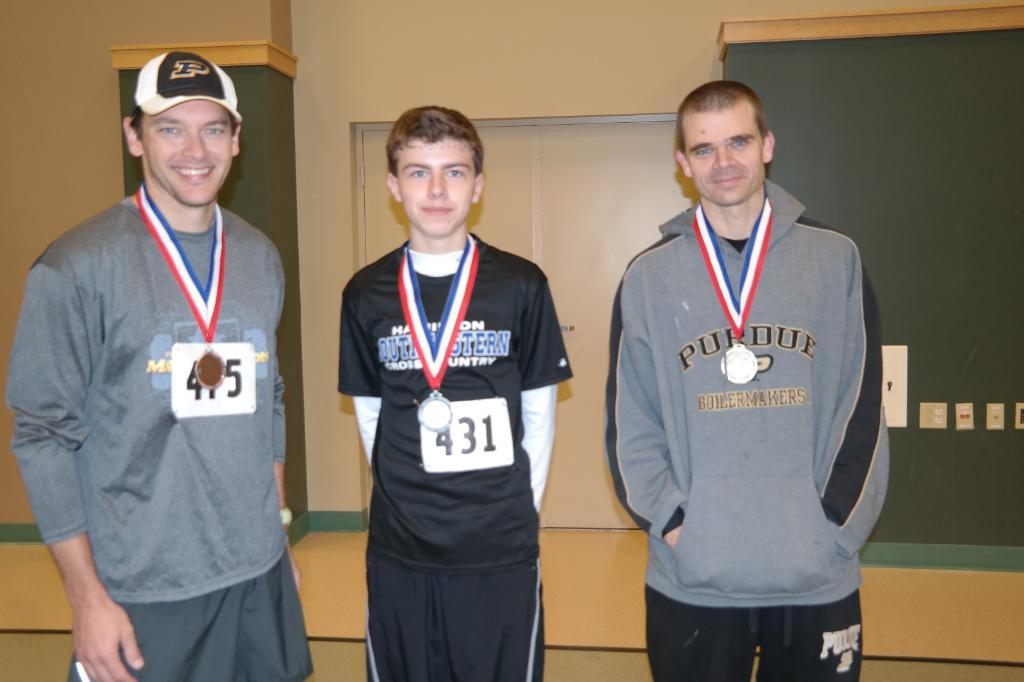<image>
Write a terse but informative summary of the picture. a man wearing a purdue boilermakers sweatshirt has a medal around his neck 